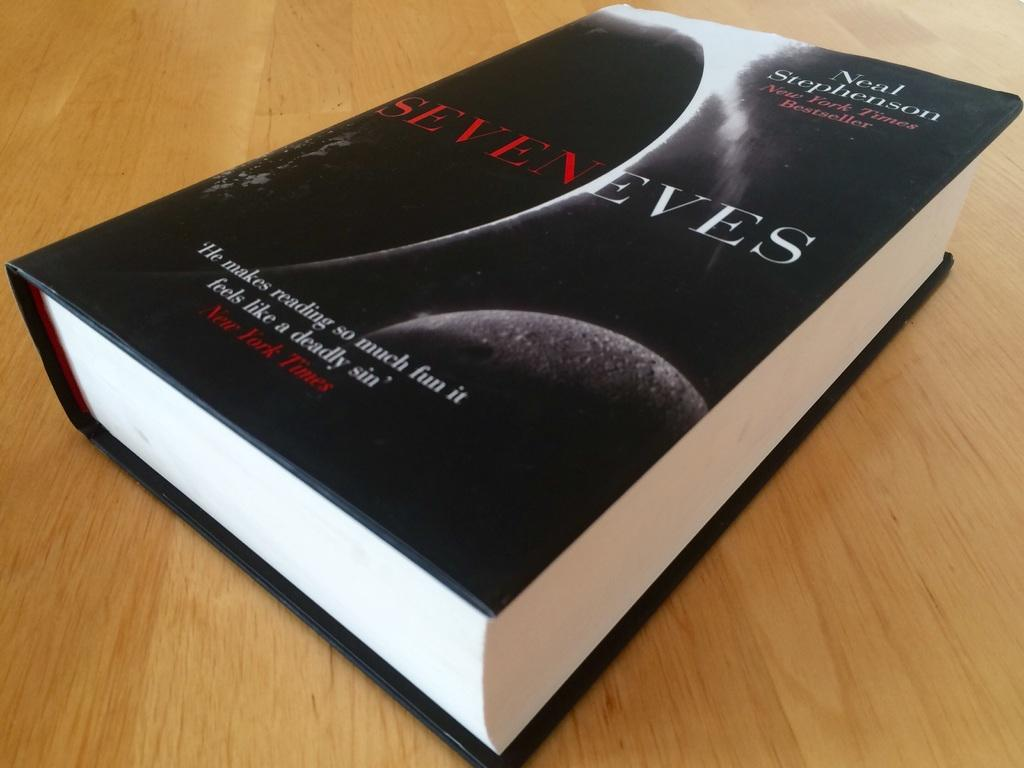<image>
Write a terse but informative summary of the picture. The new novel by Neal Stephenson "Seven Eves" is a great read. 